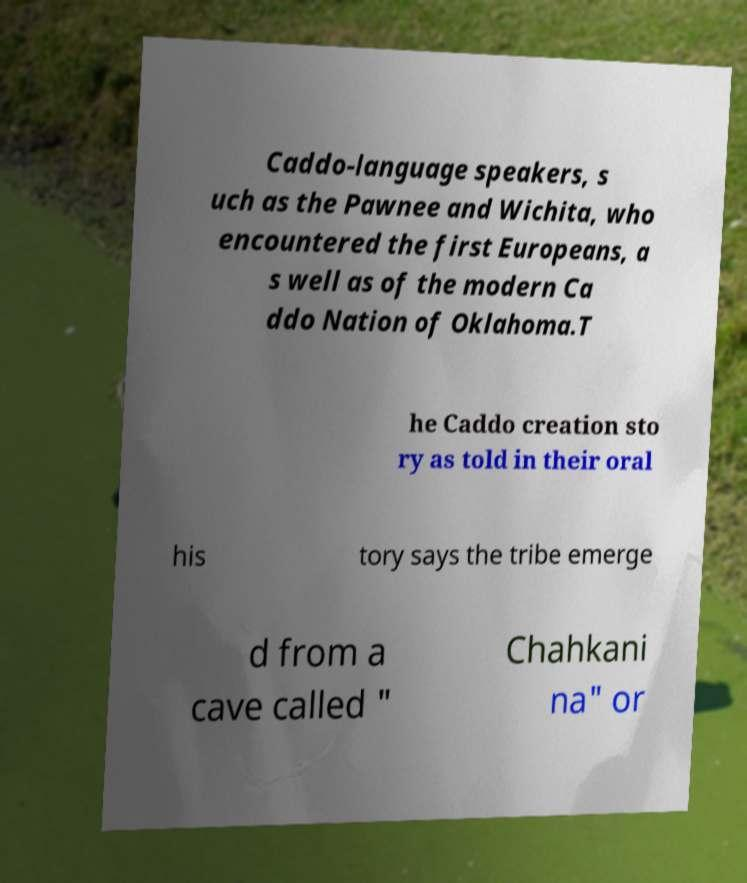What messages or text are displayed in this image? I need them in a readable, typed format. Caddo-language speakers, s uch as the Pawnee and Wichita, who encountered the first Europeans, a s well as of the modern Ca ddo Nation of Oklahoma.T he Caddo creation sto ry as told in their oral his tory says the tribe emerge d from a cave called " Chahkani na" or 